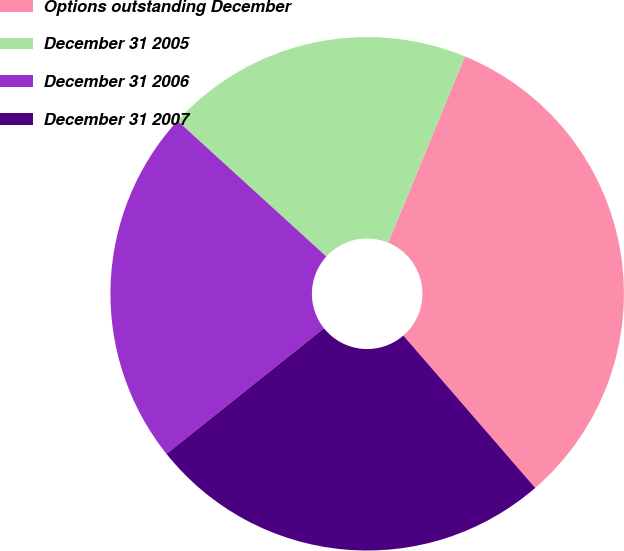<chart> <loc_0><loc_0><loc_500><loc_500><pie_chart><fcel>Options outstanding December<fcel>December 31 2005<fcel>December 31 2006<fcel>December 31 2007<nl><fcel>32.43%<fcel>19.45%<fcel>22.48%<fcel>25.64%<nl></chart> 